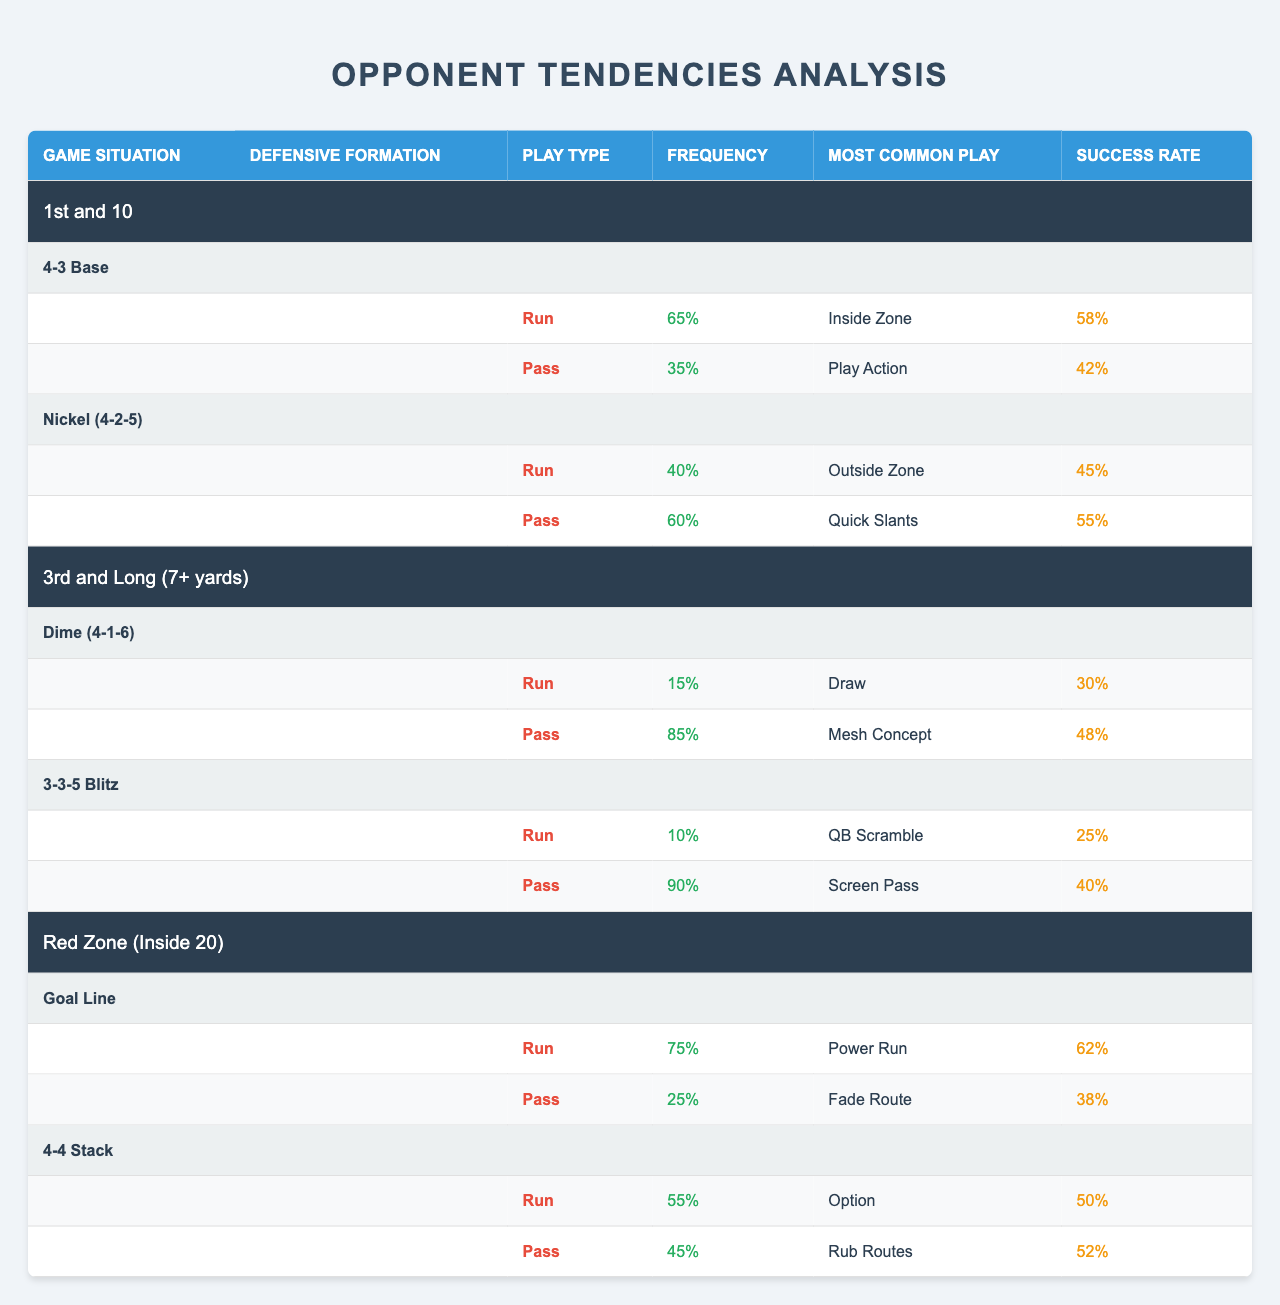What is the most common play for a run on 1st and 10 with a 4-3 Base formation? In the table, under the 1st and 10 game situation and the 4-3 Base formation, the tendency for a run lists the most common play as "Inside Zone."
Answer: Inside Zone What is the success rate of a pass play in the Red Zone for a Goal Line formation? The table indicates that under the Red Zone situation with a Goal Line formation, the pass play's success rate is 38%.
Answer: 38% How often does the opponent run the ball on 3rd and Long in a Dime formation? According to the table, the frequency of run plays in the Dime formation during 3rd and Long is 15%.
Answer: 15% Is the success rate for the most common run play higher than the success rate for the most common pass play in a Nickel (4-2-5) formation? In the Nickel (4-2-5) formation, the success rate for the most common run play "Outside Zone" is 45%, while the success rate for the most common pass play "Quick Slants" is 55%. Therefore, the pass play has a higher success rate.
Answer: No What is the average frequency of run plays across all formations in the Red Zone situation? For the Red Zone situation, the average frequency of run plays can be calculated as follows: (75% for Goal Line + 55% for 4-4 Stack) / 2 = 65%.
Answer: 65% In which game situation is the opponent most likely to pass if faced with a 3rd down scenario? In the 3rd and Long game situation, the opponent is most likely to pass with a frequency of 85% in a Dime formation.
Answer: 3rd and Long Which formation has the highest run frequency on 1st and 10? The 4-3 Base formation has the highest run frequency of 65% on 1st and 10 compared to the Nickel (4-2-5) formation.
Answer: 4-3 Base Compare the success rates of the most common pass plays in both the 4-3 Base and Nickel (4-2-5) formations on 1st and 10. For the 4-3 Base formation, the success rate for the most common pass play (Play Action) is 42%. For the Nickel (4-2-5) formation, the success rate for the most common pass play (Quick Slants) is 55%. The Nickel formation's pass play is more successful.
Answer: Nickel (4-2-5) What percentage of plays are runs when the opponent is in a 3-3-5 Blitz on 3rd and Long? The table shows that in a 3-3-5 Blitz during 3rd and Long, the opponent runs plays 10% of the time.
Answer: 10% Identify the most common play for a pass on 3rd and Long in a Dime formation and its success rate. The most common pass play in a Dime formation during 3rd and Long is "Mesh Concept," and its success rate is 48%.
Answer: Mesh Concept, 48% 